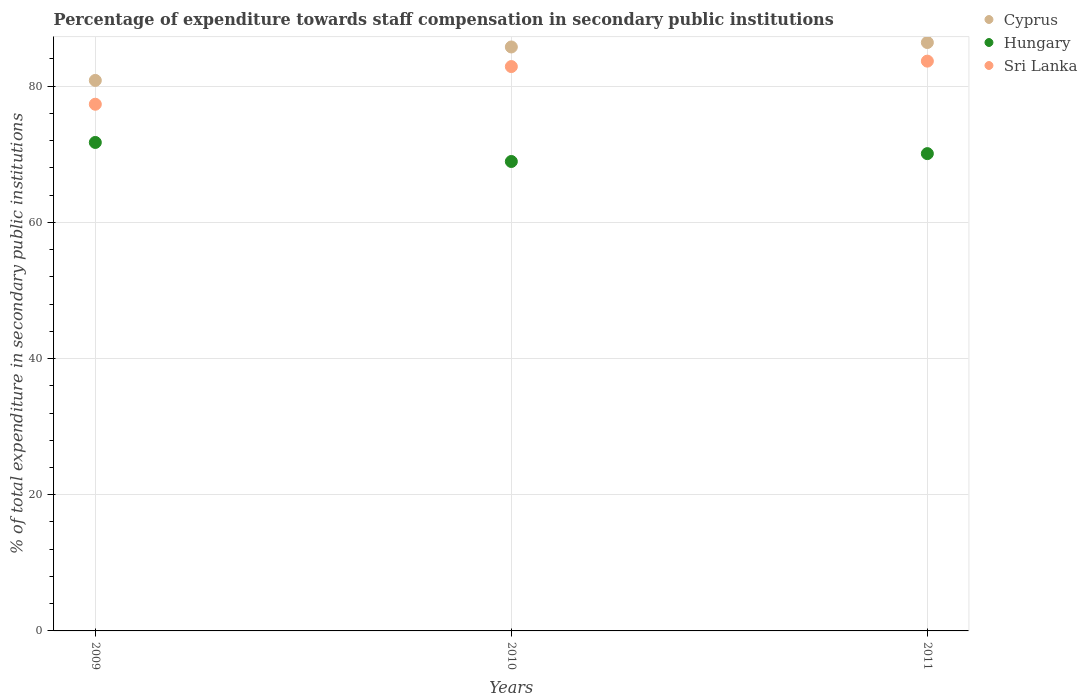How many different coloured dotlines are there?
Ensure brevity in your answer.  3. Is the number of dotlines equal to the number of legend labels?
Your answer should be very brief. Yes. What is the percentage of expenditure towards staff compensation in Sri Lanka in 2011?
Provide a short and direct response. 83.68. Across all years, what is the maximum percentage of expenditure towards staff compensation in Hungary?
Your response must be concise. 71.74. Across all years, what is the minimum percentage of expenditure towards staff compensation in Hungary?
Give a very brief answer. 68.94. In which year was the percentage of expenditure towards staff compensation in Sri Lanka maximum?
Your answer should be very brief. 2011. What is the total percentage of expenditure towards staff compensation in Cyprus in the graph?
Offer a terse response. 253.03. What is the difference between the percentage of expenditure towards staff compensation in Sri Lanka in 2009 and that in 2011?
Make the answer very short. -6.33. What is the difference between the percentage of expenditure towards staff compensation in Hungary in 2011 and the percentage of expenditure towards staff compensation in Sri Lanka in 2009?
Your answer should be compact. -7.25. What is the average percentage of expenditure towards staff compensation in Sri Lanka per year?
Make the answer very short. 81.31. In the year 2010, what is the difference between the percentage of expenditure towards staff compensation in Sri Lanka and percentage of expenditure towards staff compensation in Cyprus?
Ensure brevity in your answer.  -2.88. In how many years, is the percentage of expenditure towards staff compensation in Sri Lanka greater than 4 %?
Give a very brief answer. 3. What is the ratio of the percentage of expenditure towards staff compensation in Hungary in 2009 to that in 2010?
Provide a succinct answer. 1.04. Is the percentage of expenditure towards staff compensation in Hungary in 2009 less than that in 2010?
Give a very brief answer. No. Is the difference between the percentage of expenditure towards staff compensation in Sri Lanka in 2009 and 2010 greater than the difference between the percentage of expenditure towards staff compensation in Cyprus in 2009 and 2010?
Your answer should be compact. No. What is the difference between the highest and the second highest percentage of expenditure towards staff compensation in Sri Lanka?
Keep it short and to the point. 0.8. What is the difference between the highest and the lowest percentage of expenditure towards staff compensation in Sri Lanka?
Provide a short and direct response. 6.33. In how many years, is the percentage of expenditure towards staff compensation in Sri Lanka greater than the average percentage of expenditure towards staff compensation in Sri Lanka taken over all years?
Provide a succinct answer. 2. Does the percentage of expenditure towards staff compensation in Hungary monotonically increase over the years?
Your response must be concise. No. Is the percentage of expenditure towards staff compensation in Cyprus strictly greater than the percentage of expenditure towards staff compensation in Sri Lanka over the years?
Provide a short and direct response. Yes. Is the percentage of expenditure towards staff compensation in Cyprus strictly less than the percentage of expenditure towards staff compensation in Sri Lanka over the years?
Keep it short and to the point. No. Are the values on the major ticks of Y-axis written in scientific E-notation?
Your answer should be very brief. No. How many legend labels are there?
Provide a succinct answer. 3. What is the title of the graph?
Provide a succinct answer. Percentage of expenditure towards staff compensation in secondary public institutions. Does "French Polynesia" appear as one of the legend labels in the graph?
Ensure brevity in your answer.  No. What is the label or title of the X-axis?
Provide a short and direct response. Years. What is the label or title of the Y-axis?
Keep it short and to the point. % of total expenditure in secondary public institutions. What is the % of total expenditure in secondary public institutions in Cyprus in 2009?
Offer a terse response. 80.85. What is the % of total expenditure in secondary public institutions in Hungary in 2009?
Your answer should be compact. 71.74. What is the % of total expenditure in secondary public institutions in Sri Lanka in 2009?
Your response must be concise. 77.35. What is the % of total expenditure in secondary public institutions of Cyprus in 2010?
Make the answer very short. 85.76. What is the % of total expenditure in secondary public institutions in Hungary in 2010?
Your answer should be very brief. 68.94. What is the % of total expenditure in secondary public institutions of Sri Lanka in 2010?
Keep it short and to the point. 82.88. What is the % of total expenditure in secondary public institutions in Cyprus in 2011?
Give a very brief answer. 86.42. What is the % of total expenditure in secondary public institutions of Hungary in 2011?
Provide a succinct answer. 70.1. What is the % of total expenditure in secondary public institutions in Sri Lanka in 2011?
Give a very brief answer. 83.68. Across all years, what is the maximum % of total expenditure in secondary public institutions in Cyprus?
Provide a short and direct response. 86.42. Across all years, what is the maximum % of total expenditure in secondary public institutions of Hungary?
Your answer should be very brief. 71.74. Across all years, what is the maximum % of total expenditure in secondary public institutions in Sri Lanka?
Your answer should be very brief. 83.68. Across all years, what is the minimum % of total expenditure in secondary public institutions in Cyprus?
Provide a short and direct response. 80.85. Across all years, what is the minimum % of total expenditure in secondary public institutions in Hungary?
Offer a very short reply. 68.94. Across all years, what is the minimum % of total expenditure in secondary public institutions of Sri Lanka?
Your response must be concise. 77.35. What is the total % of total expenditure in secondary public institutions in Cyprus in the graph?
Your answer should be very brief. 253.03. What is the total % of total expenditure in secondary public institutions of Hungary in the graph?
Offer a terse response. 210.78. What is the total % of total expenditure in secondary public institutions of Sri Lanka in the graph?
Your answer should be compact. 243.92. What is the difference between the % of total expenditure in secondary public institutions in Cyprus in 2009 and that in 2010?
Provide a short and direct response. -4.91. What is the difference between the % of total expenditure in secondary public institutions in Hungary in 2009 and that in 2010?
Keep it short and to the point. 2.8. What is the difference between the % of total expenditure in secondary public institutions in Sri Lanka in 2009 and that in 2010?
Provide a succinct answer. -5.53. What is the difference between the % of total expenditure in secondary public institutions in Cyprus in 2009 and that in 2011?
Offer a terse response. -5.57. What is the difference between the % of total expenditure in secondary public institutions in Hungary in 2009 and that in 2011?
Provide a succinct answer. 1.64. What is the difference between the % of total expenditure in secondary public institutions of Sri Lanka in 2009 and that in 2011?
Your answer should be very brief. -6.33. What is the difference between the % of total expenditure in secondary public institutions of Cyprus in 2010 and that in 2011?
Keep it short and to the point. -0.65. What is the difference between the % of total expenditure in secondary public institutions of Hungary in 2010 and that in 2011?
Offer a very short reply. -1.16. What is the difference between the % of total expenditure in secondary public institutions of Sri Lanka in 2010 and that in 2011?
Keep it short and to the point. -0.8. What is the difference between the % of total expenditure in secondary public institutions of Cyprus in 2009 and the % of total expenditure in secondary public institutions of Hungary in 2010?
Offer a very short reply. 11.91. What is the difference between the % of total expenditure in secondary public institutions in Cyprus in 2009 and the % of total expenditure in secondary public institutions in Sri Lanka in 2010?
Your response must be concise. -2.03. What is the difference between the % of total expenditure in secondary public institutions in Hungary in 2009 and the % of total expenditure in secondary public institutions in Sri Lanka in 2010?
Ensure brevity in your answer.  -11.14. What is the difference between the % of total expenditure in secondary public institutions in Cyprus in 2009 and the % of total expenditure in secondary public institutions in Hungary in 2011?
Your answer should be very brief. 10.75. What is the difference between the % of total expenditure in secondary public institutions in Cyprus in 2009 and the % of total expenditure in secondary public institutions in Sri Lanka in 2011?
Your answer should be compact. -2.83. What is the difference between the % of total expenditure in secondary public institutions of Hungary in 2009 and the % of total expenditure in secondary public institutions of Sri Lanka in 2011?
Your response must be concise. -11.94. What is the difference between the % of total expenditure in secondary public institutions of Cyprus in 2010 and the % of total expenditure in secondary public institutions of Hungary in 2011?
Offer a very short reply. 15.66. What is the difference between the % of total expenditure in secondary public institutions of Cyprus in 2010 and the % of total expenditure in secondary public institutions of Sri Lanka in 2011?
Your answer should be compact. 2.08. What is the difference between the % of total expenditure in secondary public institutions in Hungary in 2010 and the % of total expenditure in secondary public institutions in Sri Lanka in 2011?
Your answer should be compact. -14.74. What is the average % of total expenditure in secondary public institutions in Cyprus per year?
Offer a very short reply. 84.34. What is the average % of total expenditure in secondary public institutions in Hungary per year?
Your answer should be compact. 70.26. What is the average % of total expenditure in secondary public institutions in Sri Lanka per year?
Offer a terse response. 81.31. In the year 2009, what is the difference between the % of total expenditure in secondary public institutions of Cyprus and % of total expenditure in secondary public institutions of Hungary?
Your answer should be very brief. 9.11. In the year 2009, what is the difference between the % of total expenditure in secondary public institutions of Cyprus and % of total expenditure in secondary public institutions of Sri Lanka?
Provide a short and direct response. 3.5. In the year 2009, what is the difference between the % of total expenditure in secondary public institutions in Hungary and % of total expenditure in secondary public institutions in Sri Lanka?
Your answer should be compact. -5.61. In the year 2010, what is the difference between the % of total expenditure in secondary public institutions of Cyprus and % of total expenditure in secondary public institutions of Hungary?
Provide a short and direct response. 16.82. In the year 2010, what is the difference between the % of total expenditure in secondary public institutions in Cyprus and % of total expenditure in secondary public institutions in Sri Lanka?
Ensure brevity in your answer.  2.88. In the year 2010, what is the difference between the % of total expenditure in secondary public institutions of Hungary and % of total expenditure in secondary public institutions of Sri Lanka?
Make the answer very short. -13.94. In the year 2011, what is the difference between the % of total expenditure in secondary public institutions of Cyprus and % of total expenditure in secondary public institutions of Hungary?
Your answer should be very brief. 16.32. In the year 2011, what is the difference between the % of total expenditure in secondary public institutions in Cyprus and % of total expenditure in secondary public institutions in Sri Lanka?
Your response must be concise. 2.73. In the year 2011, what is the difference between the % of total expenditure in secondary public institutions in Hungary and % of total expenditure in secondary public institutions in Sri Lanka?
Make the answer very short. -13.58. What is the ratio of the % of total expenditure in secondary public institutions in Cyprus in 2009 to that in 2010?
Provide a succinct answer. 0.94. What is the ratio of the % of total expenditure in secondary public institutions in Hungary in 2009 to that in 2010?
Your response must be concise. 1.04. What is the ratio of the % of total expenditure in secondary public institutions in Sri Lanka in 2009 to that in 2010?
Give a very brief answer. 0.93. What is the ratio of the % of total expenditure in secondary public institutions in Cyprus in 2009 to that in 2011?
Ensure brevity in your answer.  0.94. What is the ratio of the % of total expenditure in secondary public institutions in Hungary in 2009 to that in 2011?
Your response must be concise. 1.02. What is the ratio of the % of total expenditure in secondary public institutions of Sri Lanka in 2009 to that in 2011?
Offer a terse response. 0.92. What is the ratio of the % of total expenditure in secondary public institutions in Cyprus in 2010 to that in 2011?
Make the answer very short. 0.99. What is the ratio of the % of total expenditure in secondary public institutions in Hungary in 2010 to that in 2011?
Offer a terse response. 0.98. What is the ratio of the % of total expenditure in secondary public institutions in Sri Lanka in 2010 to that in 2011?
Your answer should be very brief. 0.99. What is the difference between the highest and the second highest % of total expenditure in secondary public institutions in Cyprus?
Offer a very short reply. 0.65. What is the difference between the highest and the second highest % of total expenditure in secondary public institutions in Hungary?
Keep it short and to the point. 1.64. What is the difference between the highest and the second highest % of total expenditure in secondary public institutions of Sri Lanka?
Your answer should be very brief. 0.8. What is the difference between the highest and the lowest % of total expenditure in secondary public institutions in Cyprus?
Provide a short and direct response. 5.57. What is the difference between the highest and the lowest % of total expenditure in secondary public institutions of Hungary?
Keep it short and to the point. 2.8. What is the difference between the highest and the lowest % of total expenditure in secondary public institutions of Sri Lanka?
Your answer should be very brief. 6.33. 